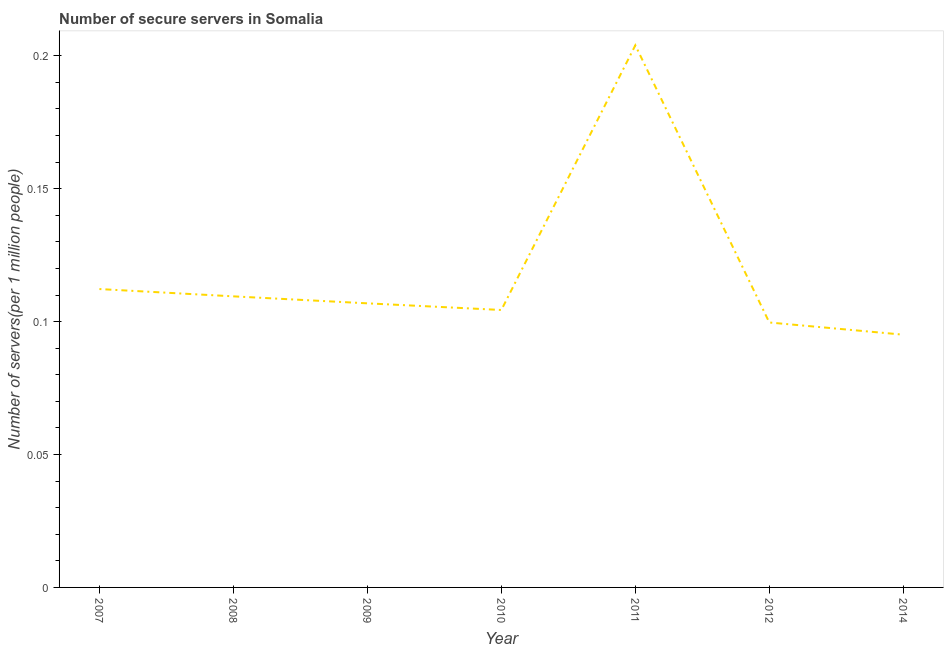What is the number of secure internet servers in 2008?
Ensure brevity in your answer.  0.11. Across all years, what is the maximum number of secure internet servers?
Your answer should be compact. 0.2. Across all years, what is the minimum number of secure internet servers?
Provide a succinct answer. 0.1. In which year was the number of secure internet servers minimum?
Your response must be concise. 2014. What is the sum of the number of secure internet servers?
Keep it short and to the point. 0.83. What is the difference between the number of secure internet servers in 2008 and 2010?
Provide a short and direct response. 0.01. What is the average number of secure internet servers per year?
Offer a very short reply. 0.12. What is the median number of secure internet servers?
Your response must be concise. 0.11. What is the ratio of the number of secure internet servers in 2010 to that in 2014?
Your answer should be compact. 1.1. Is the difference between the number of secure internet servers in 2010 and 2014 greater than the difference between any two years?
Give a very brief answer. No. What is the difference between the highest and the second highest number of secure internet servers?
Give a very brief answer. 0.09. Is the sum of the number of secure internet servers in 2007 and 2009 greater than the maximum number of secure internet servers across all years?
Your answer should be very brief. Yes. What is the difference between the highest and the lowest number of secure internet servers?
Provide a short and direct response. 0.11. In how many years, is the number of secure internet servers greater than the average number of secure internet servers taken over all years?
Your answer should be compact. 1. Does the number of secure internet servers monotonically increase over the years?
Make the answer very short. No. How many lines are there?
Provide a succinct answer. 1. Does the graph contain grids?
Provide a short and direct response. No. What is the title of the graph?
Offer a very short reply. Number of secure servers in Somalia. What is the label or title of the X-axis?
Keep it short and to the point. Year. What is the label or title of the Y-axis?
Ensure brevity in your answer.  Number of servers(per 1 million people). What is the Number of servers(per 1 million people) of 2007?
Give a very brief answer. 0.11. What is the Number of servers(per 1 million people) of 2008?
Provide a succinct answer. 0.11. What is the Number of servers(per 1 million people) of 2009?
Your answer should be compact. 0.11. What is the Number of servers(per 1 million people) in 2010?
Give a very brief answer. 0.1. What is the Number of servers(per 1 million people) of 2011?
Your response must be concise. 0.2. What is the Number of servers(per 1 million people) in 2012?
Keep it short and to the point. 0.1. What is the Number of servers(per 1 million people) in 2014?
Offer a very short reply. 0.1. What is the difference between the Number of servers(per 1 million people) in 2007 and 2008?
Make the answer very short. 0. What is the difference between the Number of servers(per 1 million people) in 2007 and 2009?
Your response must be concise. 0.01. What is the difference between the Number of servers(per 1 million people) in 2007 and 2010?
Provide a short and direct response. 0.01. What is the difference between the Number of servers(per 1 million people) in 2007 and 2011?
Ensure brevity in your answer.  -0.09. What is the difference between the Number of servers(per 1 million people) in 2007 and 2012?
Provide a succinct answer. 0.01. What is the difference between the Number of servers(per 1 million people) in 2007 and 2014?
Make the answer very short. 0.02. What is the difference between the Number of servers(per 1 million people) in 2008 and 2009?
Your answer should be very brief. 0. What is the difference between the Number of servers(per 1 million people) in 2008 and 2010?
Offer a very short reply. 0.01. What is the difference between the Number of servers(per 1 million people) in 2008 and 2011?
Offer a very short reply. -0.09. What is the difference between the Number of servers(per 1 million people) in 2008 and 2012?
Your response must be concise. 0.01. What is the difference between the Number of servers(per 1 million people) in 2008 and 2014?
Ensure brevity in your answer.  0.01. What is the difference between the Number of servers(per 1 million people) in 2009 and 2010?
Make the answer very short. 0. What is the difference between the Number of servers(per 1 million people) in 2009 and 2011?
Your answer should be very brief. -0.1. What is the difference between the Number of servers(per 1 million people) in 2009 and 2012?
Make the answer very short. 0.01. What is the difference between the Number of servers(per 1 million people) in 2009 and 2014?
Provide a succinct answer. 0.01. What is the difference between the Number of servers(per 1 million people) in 2010 and 2011?
Ensure brevity in your answer.  -0.1. What is the difference between the Number of servers(per 1 million people) in 2010 and 2012?
Offer a very short reply. 0. What is the difference between the Number of servers(per 1 million people) in 2010 and 2014?
Ensure brevity in your answer.  0.01. What is the difference between the Number of servers(per 1 million people) in 2011 and 2012?
Your answer should be very brief. 0.1. What is the difference between the Number of servers(per 1 million people) in 2011 and 2014?
Offer a terse response. 0.11. What is the difference between the Number of servers(per 1 million people) in 2012 and 2014?
Your response must be concise. 0. What is the ratio of the Number of servers(per 1 million people) in 2007 to that in 2009?
Your response must be concise. 1.05. What is the ratio of the Number of servers(per 1 million people) in 2007 to that in 2010?
Offer a very short reply. 1.08. What is the ratio of the Number of servers(per 1 million people) in 2007 to that in 2011?
Make the answer very short. 0.55. What is the ratio of the Number of servers(per 1 million people) in 2007 to that in 2012?
Offer a very short reply. 1.13. What is the ratio of the Number of servers(per 1 million people) in 2007 to that in 2014?
Ensure brevity in your answer.  1.18. What is the ratio of the Number of servers(per 1 million people) in 2008 to that in 2009?
Provide a succinct answer. 1.02. What is the ratio of the Number of servers(per 1 million people) in 2008 to that in 2010?
Offer a terse response. 1.05. What is the ratio of the Number of servers(per 1 million people) in 2008 to that in 2011?
Provide a short and direct response. 0.54. What is the ratio of the Number of servers(per 1 million people) in 2008 to that in 2012?
Provide a short and direct response. 1.1. What is the ratio of the Number of servers(per 1 million people) in 2008 to that in 2014?
Provide a succinct answer. 1.15. What is the ratio of the Number of servers(per 1 million people) in 2009 to that in 2011?
Offer a terse response. 0.52. What is the ratio of the Number of servers(per 1 million people) in 2009 to that in 2012?
Offer a terse response. 1.07. What is the ratio of the Number of servers(per 1 million people) in 2009 to that in 2014?
Offer a terse response. 1.12. What is the ratio of the Number of servers(per 1 million people) in 2010 to that in 2011?
Your response must be concise. 0.51. What is the ratio of the Number of servers(per 1 million people) in 2010 to that in 2012?
Your answer should be very brief. 1.05. What is the ratio of the Number of servers(per 1 million people) in 2010 to that in 2014?
Offer a terse response. 1.1. What is the ratio of the Number of servers(per 1 million people) in 2011 to that in 2012?
Your response must be concise. 2.05. What is the ratio of the Number of servers(per 1 million people) in 2011 to that in 2014?
Give a very brief answer. 2.15. What is the ratio of the Number of servers(per 1 million people) in 2012 to that in 2014?
Offer a terse response. 1.05. 